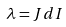<formula> <loc_0><loc_0><loc_500><loc_500>\lambda = J d I</formula> 